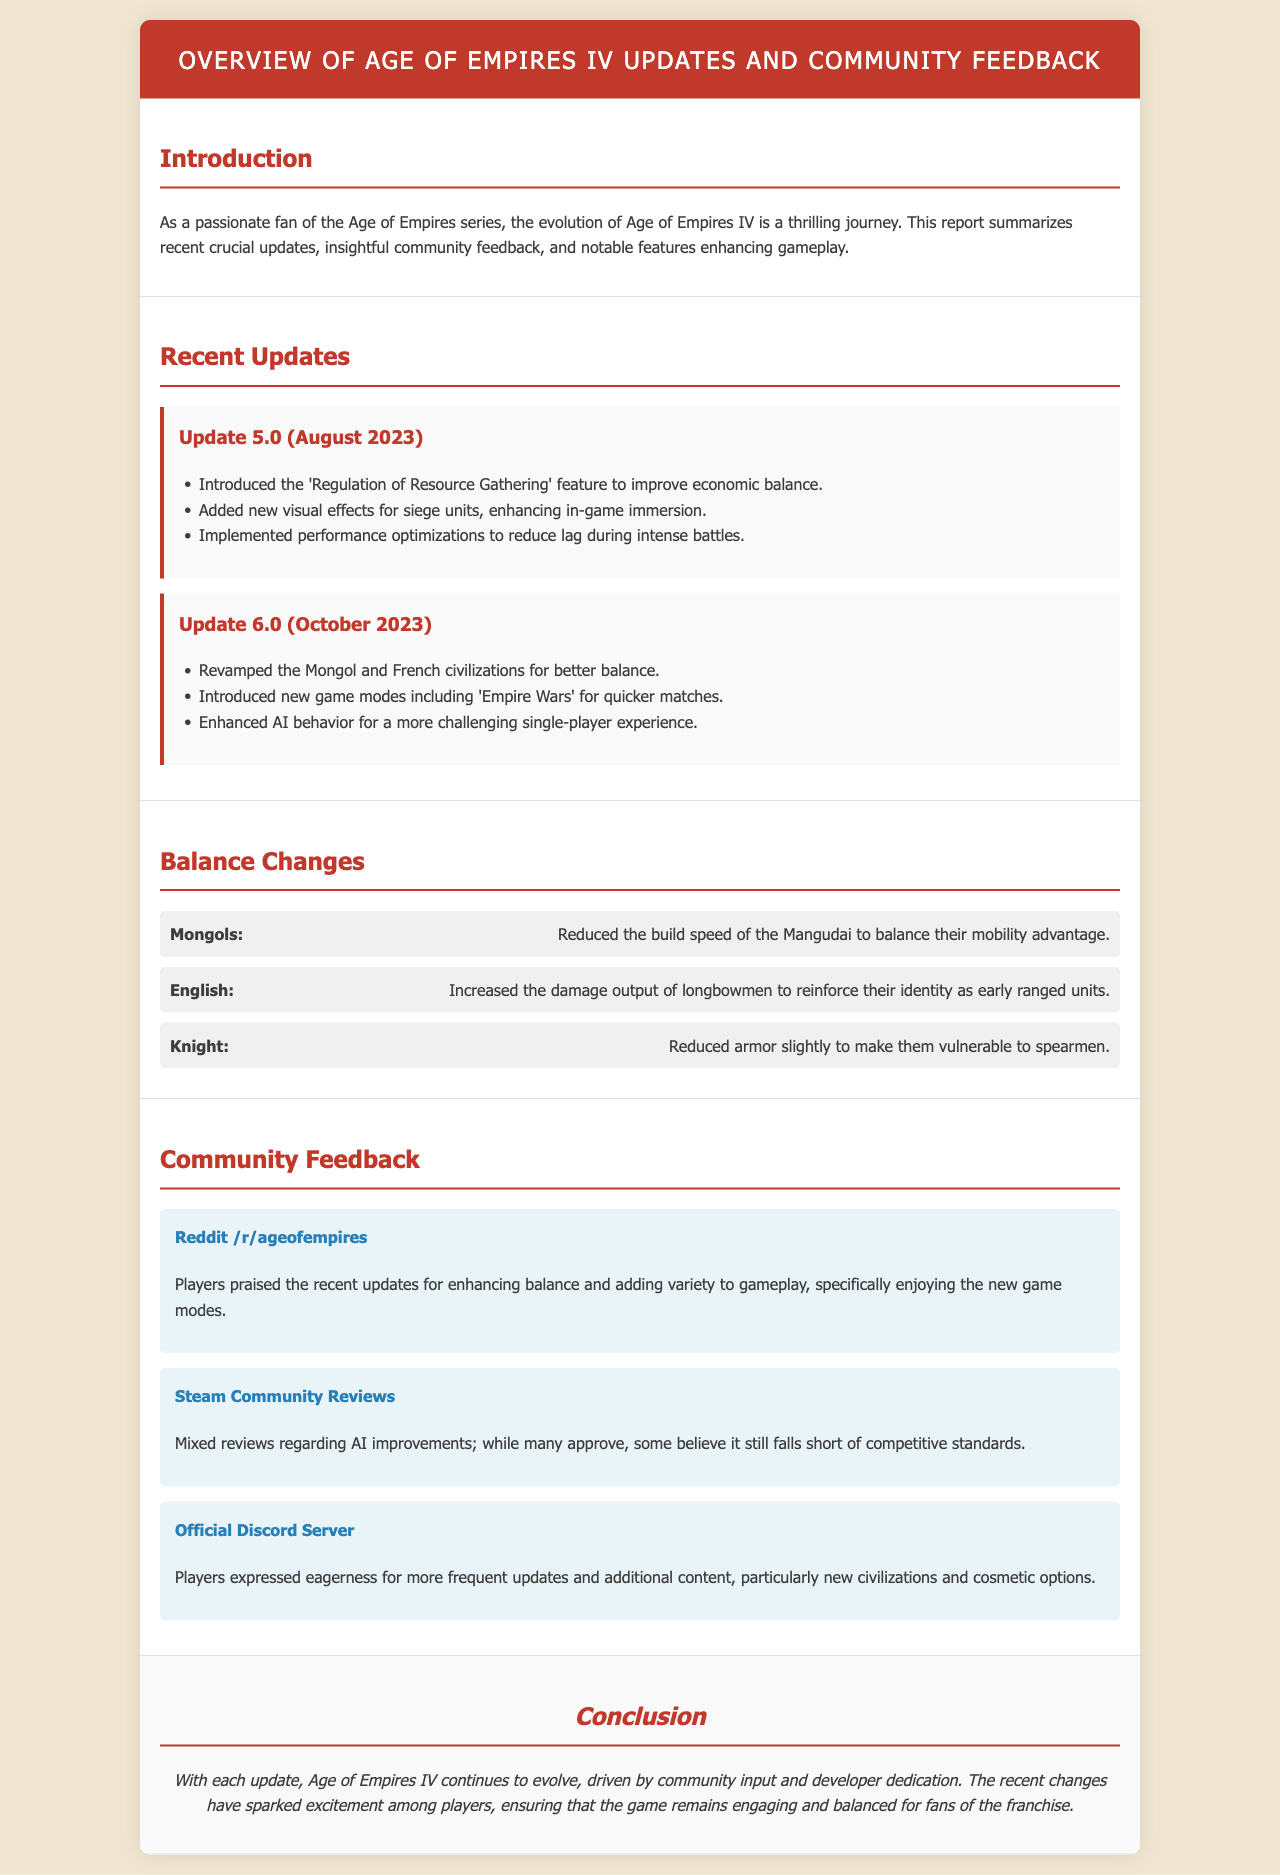What is the title of the report? The title of the report is included in the header section of the document.
Answer: Overview of Age of Empires IV Updates and Community Feedback When was Update 6.0 released? The release date of Update 6.0 can be found in the section detailing recent updates.
Answer: October 2023 What new game modes were introduced in Update 6.0? The new game modes are specifically listed under the Update 6.0 section of recent updates.
Answer: Empire Wars Which civilization's longbowmen damage output was increased? The specific civilization mentioned for changes in the balance section can be found related to the longbowmen.
Answer: English What did players express eagerness for in the Official Discord Server? The feedback from the community section includes what players are looking for on Discord.
Answer: More frequent updates How did the community react to the AI improvements? The sentiment regarding AI improvements is discussed in the Steam Community Reviews section.
Answer: Mixed reviews What feature was introduced to enhance economic balance in Update 5.0? Specific features from the updates section can be referenced for this answer.
Answer: Regulation of Resource Gathering Which civilization's Mangudai build speed was reduced? The balance changes section specifies which civilization had its unit affected.
Answer: Mongols 